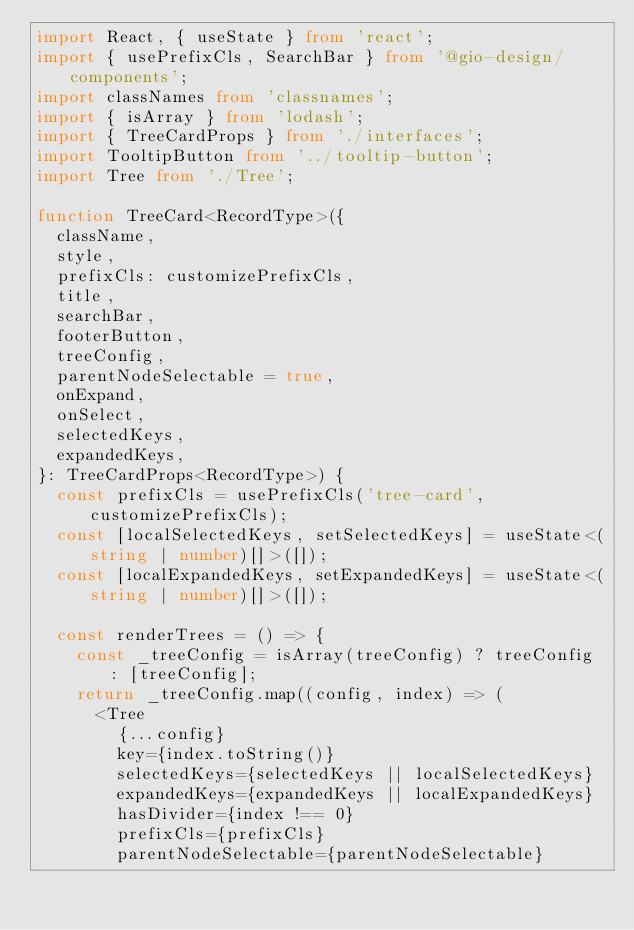Convert code to text. <code><loc_0><loc_0><loc_500><loc_500><_TypeScript_>import React, { useState } from 'react';
import { usePrefixCls, SearchBar } from '@gio-design/components';
import classNames from 'classnames';
import { isArray } from 'lodash';
import { TreeCardProps } from './interfaces';
import TooltipButton from '../tooltip-button';
import Tree from './Tree';

function TreeCard<RecordType>({
  className,
  style,
  prefixCls: customizePrefixCls,
  title,
  searchBar,
  footerButton,
  treeConfig,
  parentNodeSelectable = true,
  onExpand,
  onSelect,
  selectedKeys,
  expandedKeys,
}: TreeCardProps<RecordType>) {
  const prefixCls = usePrefixCls('tree-card', customizePrefixCls);
  const [localSelectedKeys, setSelectedKeys] = useState<(string | number)[]>([]);
  const [localExpandedKeys, setExpandedKeys] = useState<(string | number)[]>([]);

  const renderTrees = () => {
    const _treeConfig = isArray(treeConfig) ? treeConfig : [treeConfig];
    return _treeConfig.map((config, index) => (
      <Tree
        {...config}
        key={index.toString()}
        selectedKeys={selectedKeys || localSelectedKeys}
        expandedKeys={expandedKeys || localExpandedKeys}
        hasDivider={index !== 0}
        prefixCls={prefixCls}
        parentNodeSelectable={parentNodeSelectable}</code> 